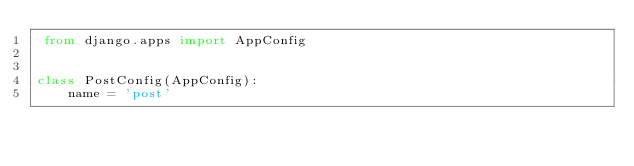Convert code to text. <code><loc_0><loc_0><loc_500><loc_500><_Python_> from django.apps import AppConfig


class PostConfig(AppConfig):
    name = 'post'
</code> 